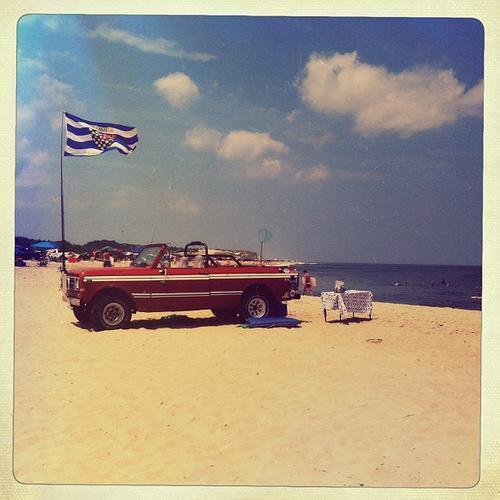How many flags are there?
Give a very brief answer. 1. 